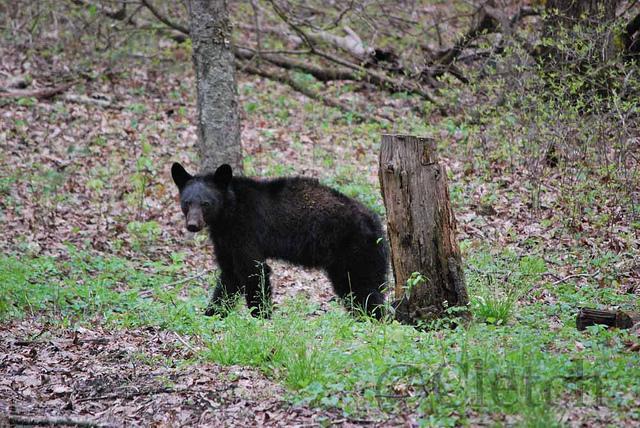How many men are in the image?
Give a very brief answer. 0. 